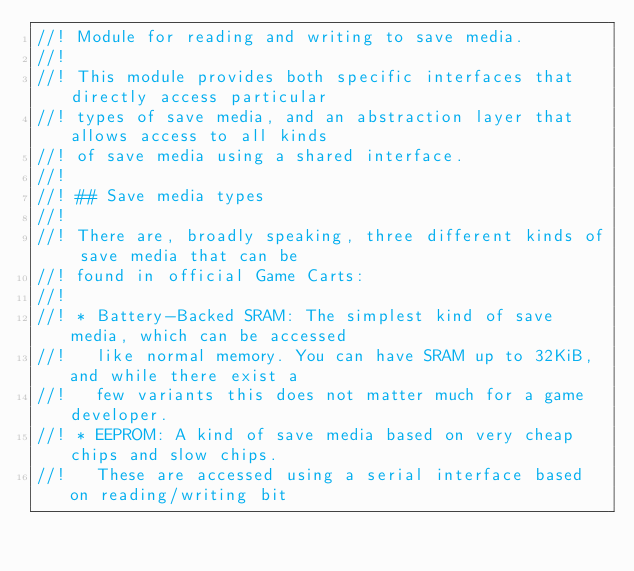<code> <loc_0><loc_0><loc_500><loc_500><_Rust_>//! Module for reading and writing to save media.
//!
//! This module provides both specific interfaces that directly access particular
//! types of save media, and an abstraction layer that allows access to all kinds
//! of save media using a shared interface.
//!
//! ## Save media types
//!
//! There are, broadly speaking, three different kinds of save media that can be
//! found in official Game Carts:
//!
//! * Battery-Backed SRAM: The simplest kind of save media, which can be accessed
//!   like normal memory. You can have SRAM up to 32KiB, and while there exist a
//!   few variants this does not matter much for a game developer.
//! * EEPROM: A kind of save media based on very cheap chips and slow chips.
//!   These are accessed using a serial interface based on reading/writing bit</code> 